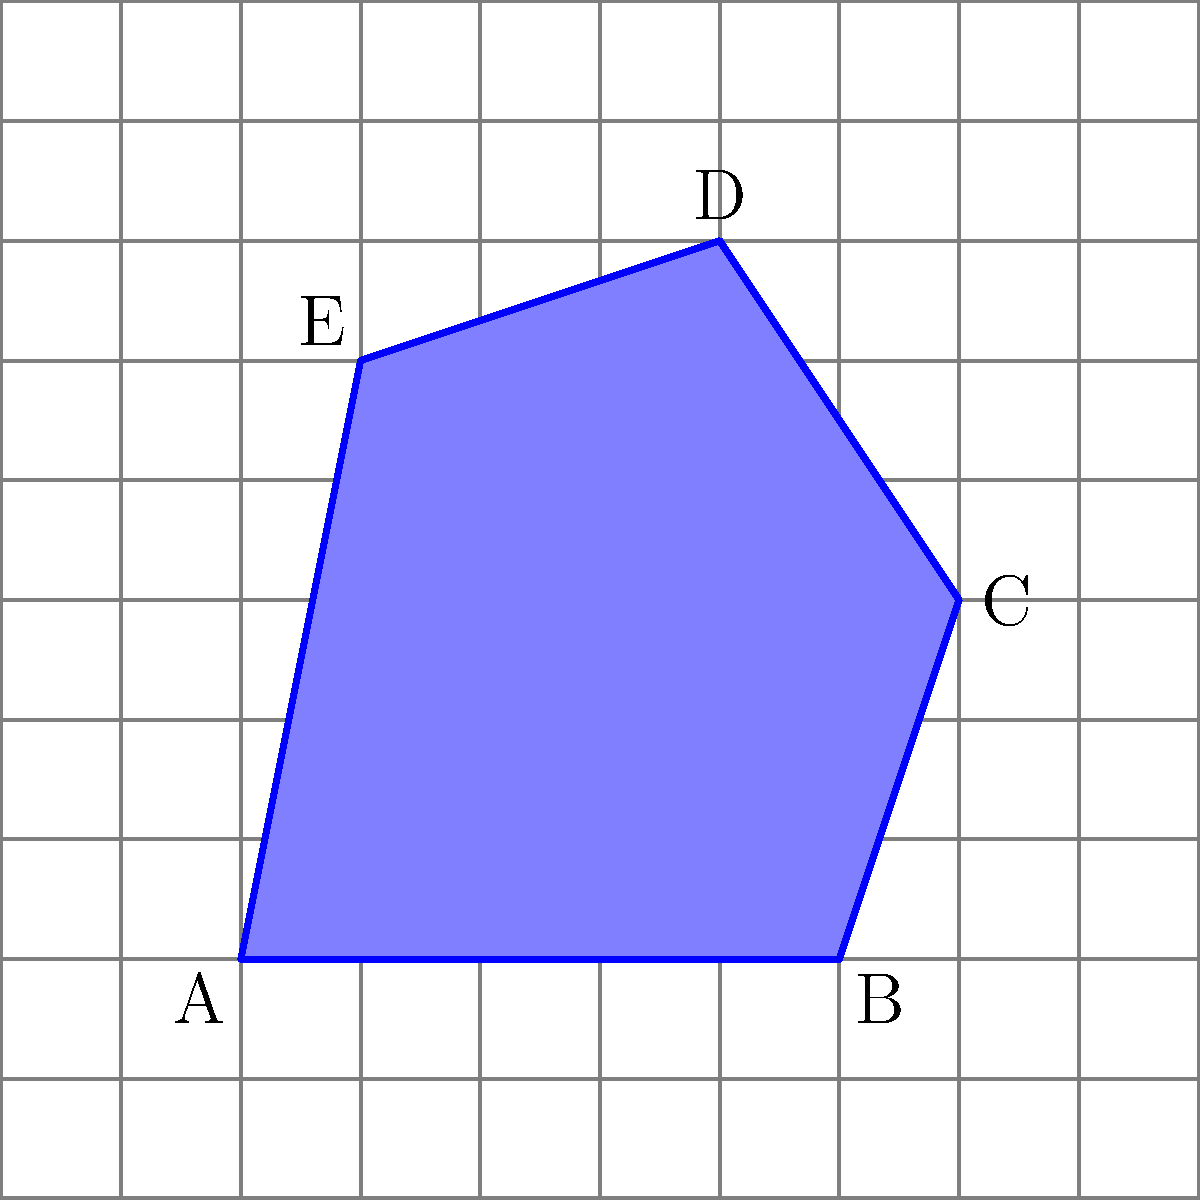As a software developer working on an up-to-date project, you're tasked with implementing a feature to calculate the area of irregular polygons using a grid overlay method. Given the irregular polygon ABCDE shown in the grid above, where each grid square represents 1 square unit, determine the approximate area of the polygon using the counting squares method. Round your answer to the nearest whole number. To calculate the approximate area of the irregular polygon using the counting squares method, we'll follow these steps:

1. Count the full squares inside the polygon:
   There are approximately 25 full squares inside the polygon.

2. Count the partial squares along the edges:
   There are about 16 partial squares along the edges of the polygon.

3. Estimate the area of partial squares:
   Assume that, on average, each partial square contributes half of its area.
   Partial squares contribution: $16 \times 0.5 = 8$ square units

4. Sum up the total area:
   Total area = Full squares + Partial squares contribution
   Total area = $25 + 8 = 33$ square units

5. Round to the nearest whole number:
   The result is already a whole number, so no rounding is necessary.

Therefore, the approximate area of the irregular polygon ABCDE is 33 square units.
Answer: 33 square units 